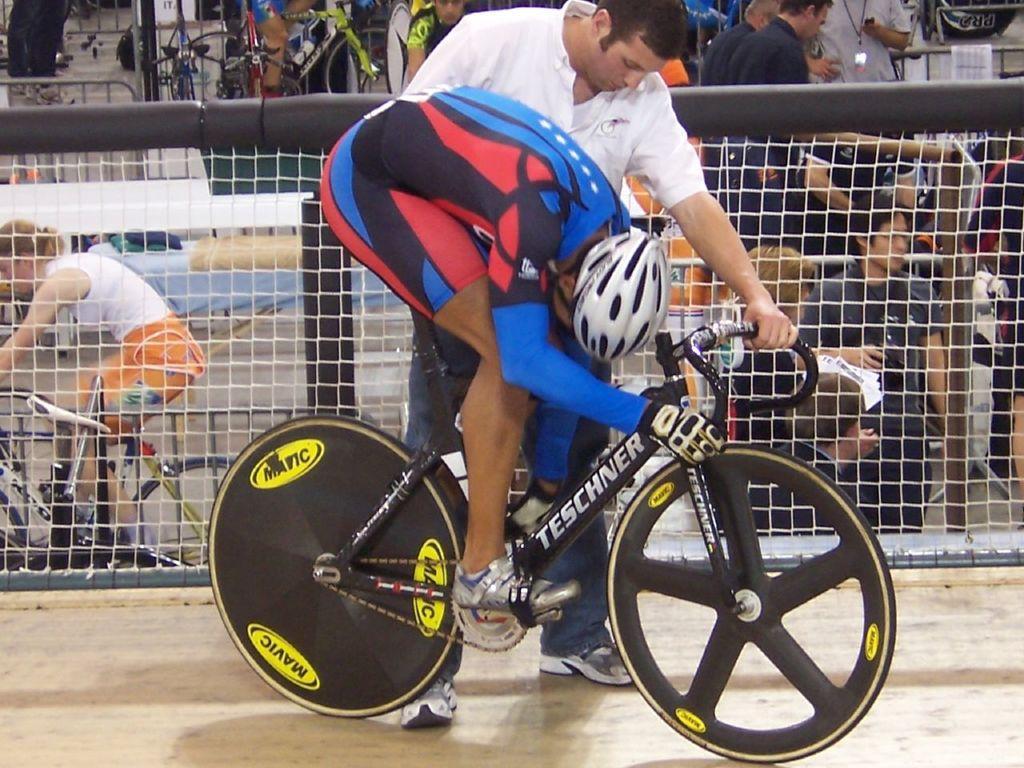Can you describe this image briefly? In this image, we can see persons wearing clothes. There is a person in the middle of the image riding a bicycle. There is an another person beside the fencing holding a cycle handle with his hand. 